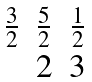<formula> <loc_0><loc_0><loc_500><loc_500>\begin{matrix} \frac { 3 } { 2 } & \frac { 5 } { 2 } & \frac { 1 } { 2 } \\ & 2 & 3 \end{matrix}</formula> 